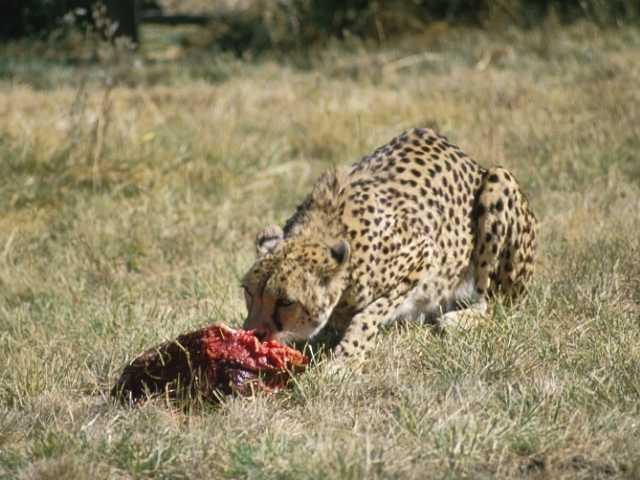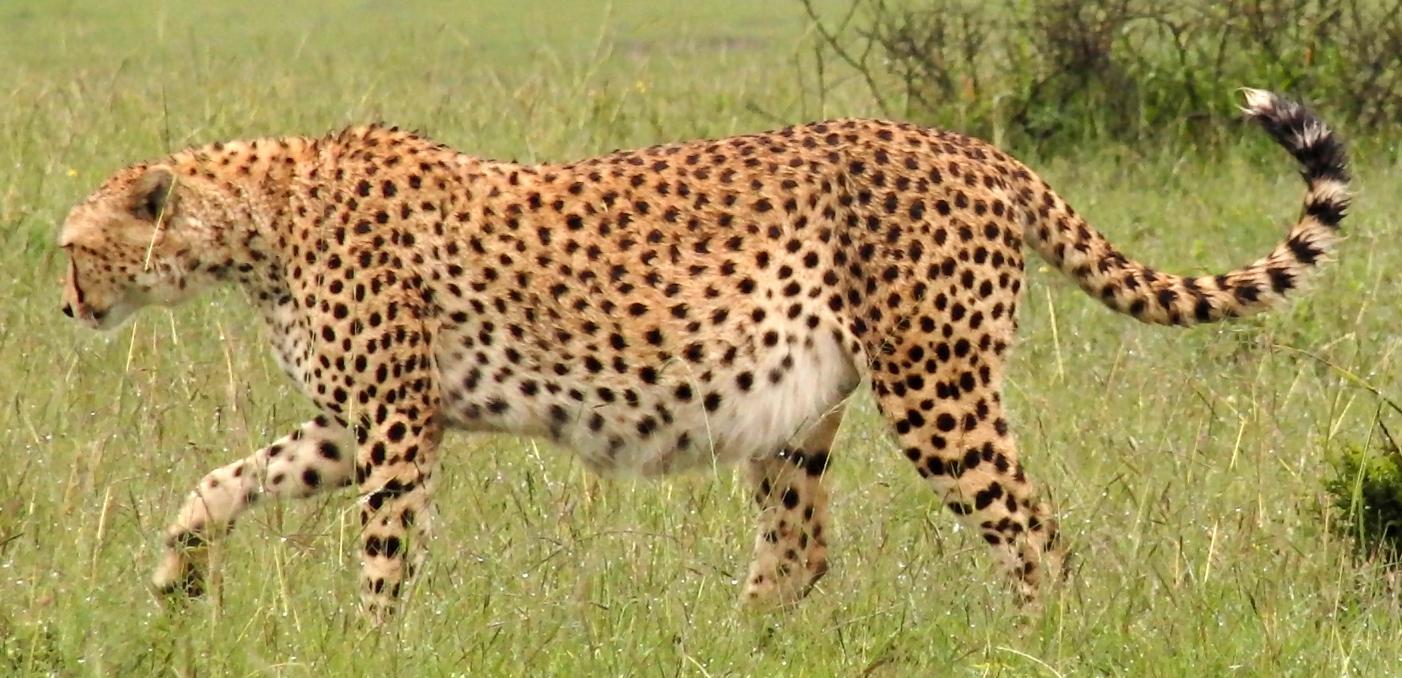The first image is the image on the left, the second image is the image on the right. For the images shown, is this caption "The left image shows a forward angled adult cheetah on the grass on its haunches with a piece of red flesh in front of it." true? Answer yes or no. Yes. The first image is the image on the left, the second image is the image on the right. For the images displayed, is the sentence "One cheetah's teeth are visible." factually correct? Answer yes or no. No. 